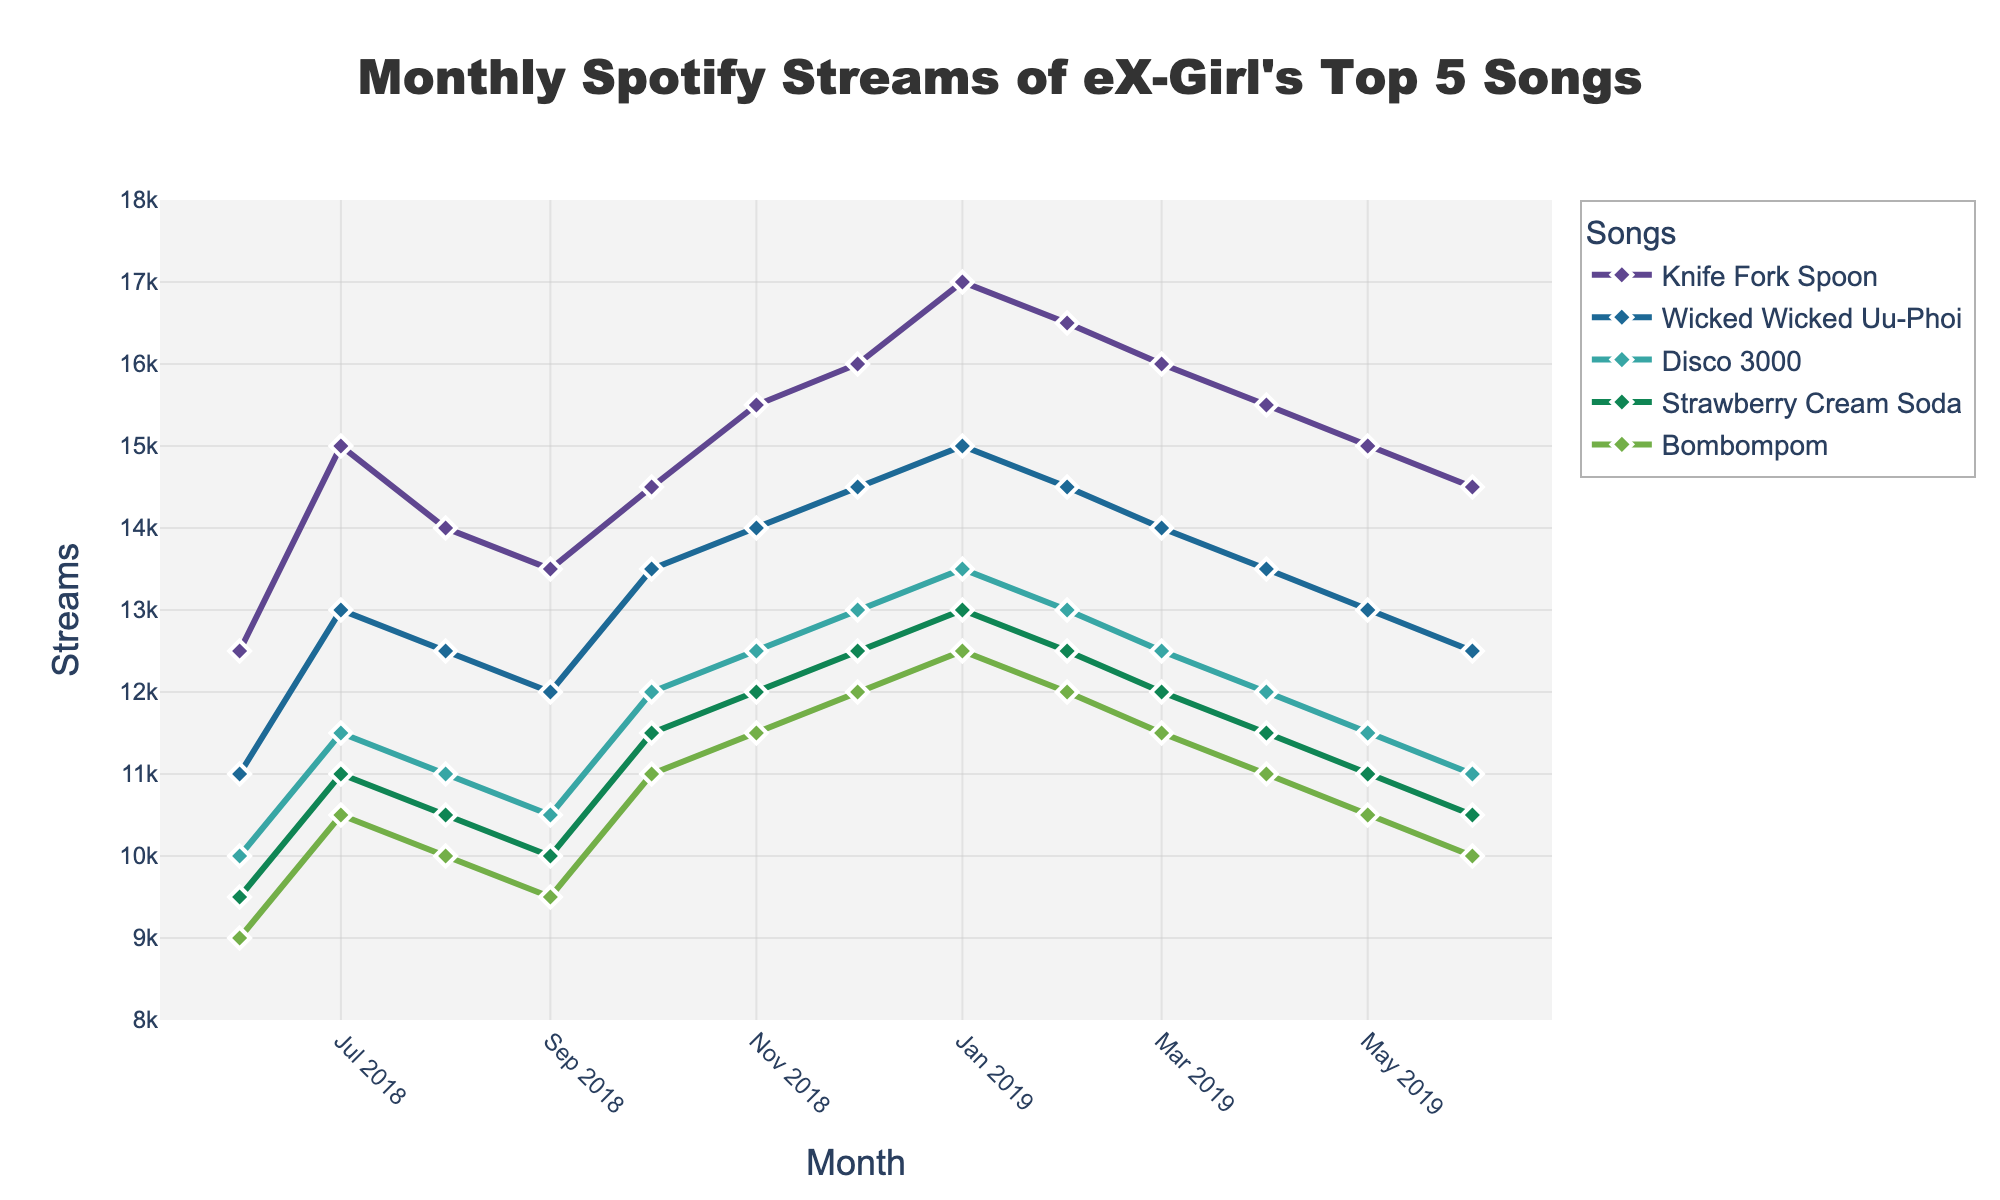Which song had the highest number of streams in January 2019? Looking at the plot, identify the highest point in January 2019 and note which song it corresponds to. 'Knife Fork Spoon' has the highest value around 17000 streams.
Answer: Knife Fork Spoon Which song showed the largest increase in monthly streams between July and August 2018? Compare the increase in streams for each song between July and August 2018. 'Disco 3000' shows an incremental increase of 500 streams from 11500 to 11000.
Answer: Disco 3000 What is the average monthly stream count for 'Strawberry Cream Soda' from June 2018 to June 2019? To find the average, sum the streams from June 2018 to June 2019 and divide by 13 (total months). Sum: 9500+11000+10500+10000+11500+12000+12500+13000+12500+12000+11500+11000+10500 = 153500. Average: 153500/13 = 11807.7
Answer: 11807.7 Which song has the least variation in streams over the period shown? The least variation would be the song with the flattest trend line over the time period. 'Wicked Wicked Uu-Phoi' shows relatively stable streams around 14000.
Answer: Wicked Wicked Uu-Phoi Which two months had the biggest drop in streams for 'Bombompom'? Find the two consecutive months where the drop in streams for 'Bombompom' is the largest. The biggest drop is between January 2019 (12500) and February 2019 (12000), a drop of 500.
Answer: January 2019 and February 2019 How does the trend in streams for 'Knife Fork Spoon' compare to that of 'Wicked Wicked Uu-Phoi' over the first six months? Compare the slopes of the lines representing 'Knife Fork Spoon' and 'Wicked Wicked Uu-Phoi' from June 2018 to November 2018. 'Knife Fork Spoon' has a generally upward trend, while 'Wicked Wicked Uu-Phoi' is more stable with a slight increase.
Answer: Knife Fork Spoon has an increasing trend, while Wicked Wicked Uu-Phoi is more stable What is the overall trend for 'Disco 3000' from June 2018 to June 2019? Observe the plot line for 'Disco 3000' and summarize its direction. The plot shows a slight increase at the beginning, peaking in January 2019 and then gradually decreasing.
Answer: Slight increase then gradual decrease Which month had the highest combined streams for all five songs? Sum the streams for all songs for each month and identify the month with the highest total. January 2019 has the highest combined count.
Answer: January 2019 